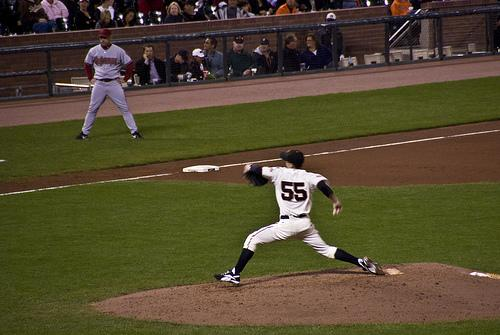In a short sentence, provide an analysis of the baseball player's body movement. The baseball player's arm, leg, and body posture indicate that he is in the process of pitching the ball. What emotions might be associated with this image? Anticipation, excitement, focus, and competitiveness. What is the main action being performed by the central figure in the image? A man on the pitching mound is throwing a baseball. Identify three objects related to the sport being played in the image. Pitching mound, baseball, white base on dirt. Combine two object-related captions to form a complex statement about the baseball player. The pitcher wearing a black baseball hat and a numbered jersey is throwing a baseball on the pitching mound. List the colors and types of clothing worn by the man throwing the baseball. Black baseball hat, black long sleeve under shirt, black baseball socks, black and white cleats, numbered jersey. Examine the image and rate its quality from 1 to 5, with 5 being the highest quality. 3 (assuming a subjective judgement of the quality) Provide a brief description of the footwear worn by the baseball player. Black and white cleats on the baseball player's feet. Can you describe the scene of people spectating the sporting event? People sitting and watching the baseball game wearing various colored shirts and caps. How many instances of thin clouds in the very dark sky can you identify in the image? Nine instances of thin clouds in the very dark sky. Which objects can be identified on the baseball field related to the game? The objects are the pitcher's mound, white base on dirt, white chalk line across the field, and the plate. Provide a short, descriptive caption for the image. A baseball player throws the ball from the pitcher's mound during a major league game. How many people can be seen wearing a gray shirt in the image? One person is wearing a grey shirt. Write a brief sentence that summarizes the event taking place in the image. A pitcher is about to pitch the ball during a major league baseball game. Which parts of the baseball player can be identified in the image? Head, legs, arms, fingers, back, and waist belt can be identified. Describe the outfit of the baseball player on the pitcher's mound. He is wearing a cap, black long sleeve undershirt, black baseball socks, black and white cleats, and a jersey with a number on top. What type of sky is depicted in the image, and what are its features? The sky is very dark with thin clouds scattered throughout. Can you see the green long sleeve shirt under the baseball player's jersey? The image recognizes a black long sleeve under shirt, not green. Asking about a green shirt leads to confusion. What is the man standing on the pitcher's mound doing? The man is throwing a baseball. Which of these details can be seen in the image: thick clouds, black fence, or red cap? Black fence and red cap. Is the baseball player's jersey number 23? The image recognizes a number on top of the jersey but does not indicate it is 23, so it is misleading to ask about a specific number that is not mentioned. Is the baseball player's jersey number visible, and if so, what is the number? Yes, the number is visible, and it is 55. How many different objects or elements in the image are described as having thin clouds in the sky? 9 different objects or elements. Is there an audience watching the baseball game, and if so, what are they doing? Yes, there are people sitting and watching the baseball game. Describe the footwear of the pitcher on the mound. Black and white cleats. What are the outerwear clothing items of the baseball player? Black long sleeve undershirt and black baseball socks. Is the baseball player standing at third base? The image recognizes a baseball player standing at a base but does not specify third base. Asking about a specific base can be misleading since the information is not provided. Choose the correct description: A playground filled with children or a major league baseball game. A major league baseball game. Are there purple clouds in the sky? The image recognizes thin clouds in the very dark sky, but no mention of a purple color. Asking about purple clouds can be misleading. Is there a player with a red cap in the image? Yes, there is a player wearing a red cap. Find the person wearing an orange shirt. There is a person wearing an orange shirt at the top-left corner of the image. Does the image show a basketball game happening in the background? The image only mentions a baseball game, and there is no information suggesting a basketball game. So, asking about a basketball game is misleading. Is the man on the pitching mound wearing a blue hat? The image recognizes a black baseball hat on the man, but the instruction asks if the hat is blue, which is misleading. Identify the various labels and details on the baseball player's outfit and equipment. There's a number 55 on the jersey, a black baseball cap, and black and white cleats. 